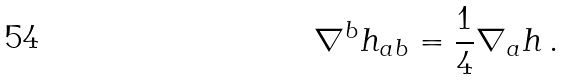<formula> <loc_0><loc_0><loc_500><loc_500>\nabla ^ { b } h _ { a b } = \frac { 1 } { 4 } \nabla _ { a } h \, .</formula> 